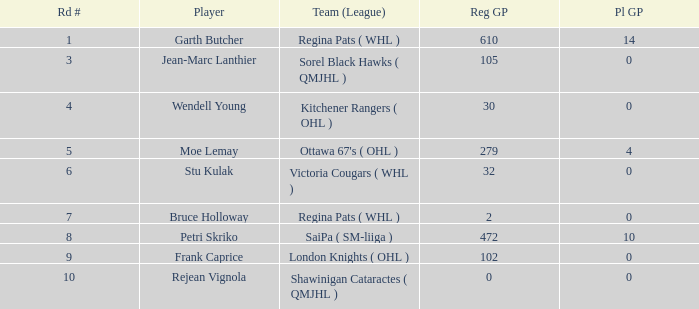What is the average street number when moe lemay is the player? 5.0. 